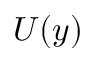<formula> <loc_0><loc_0><loc_500><loc_500>U ( y )</formula> 